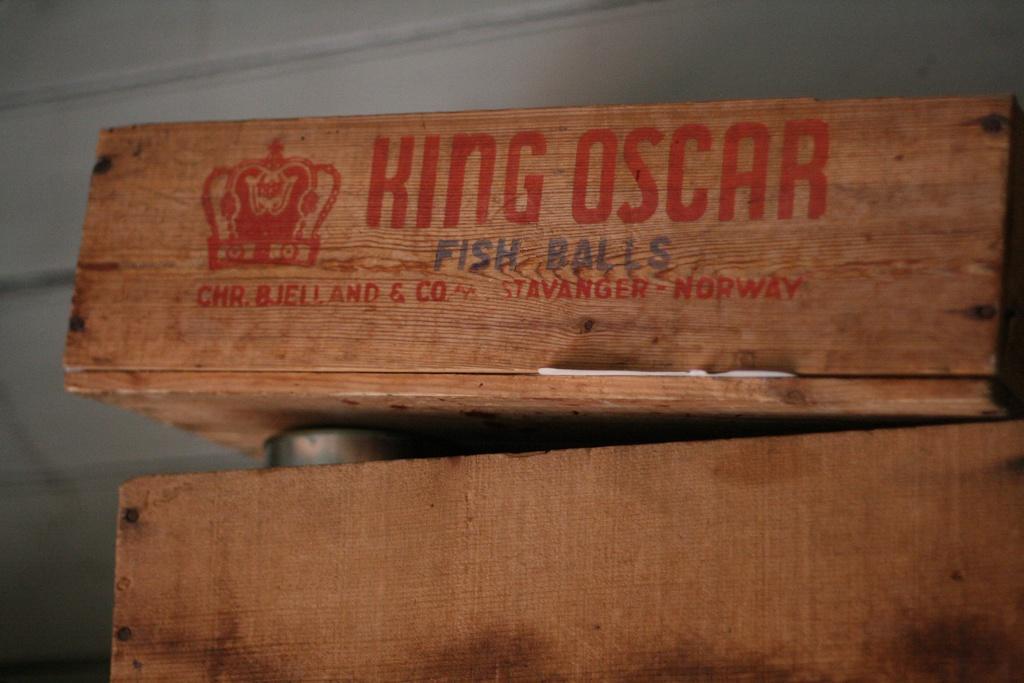Please provide a concise description of this image. In this image the front there is a wooden Box with some text written on it and in the background there is a wall which is white in colour. 